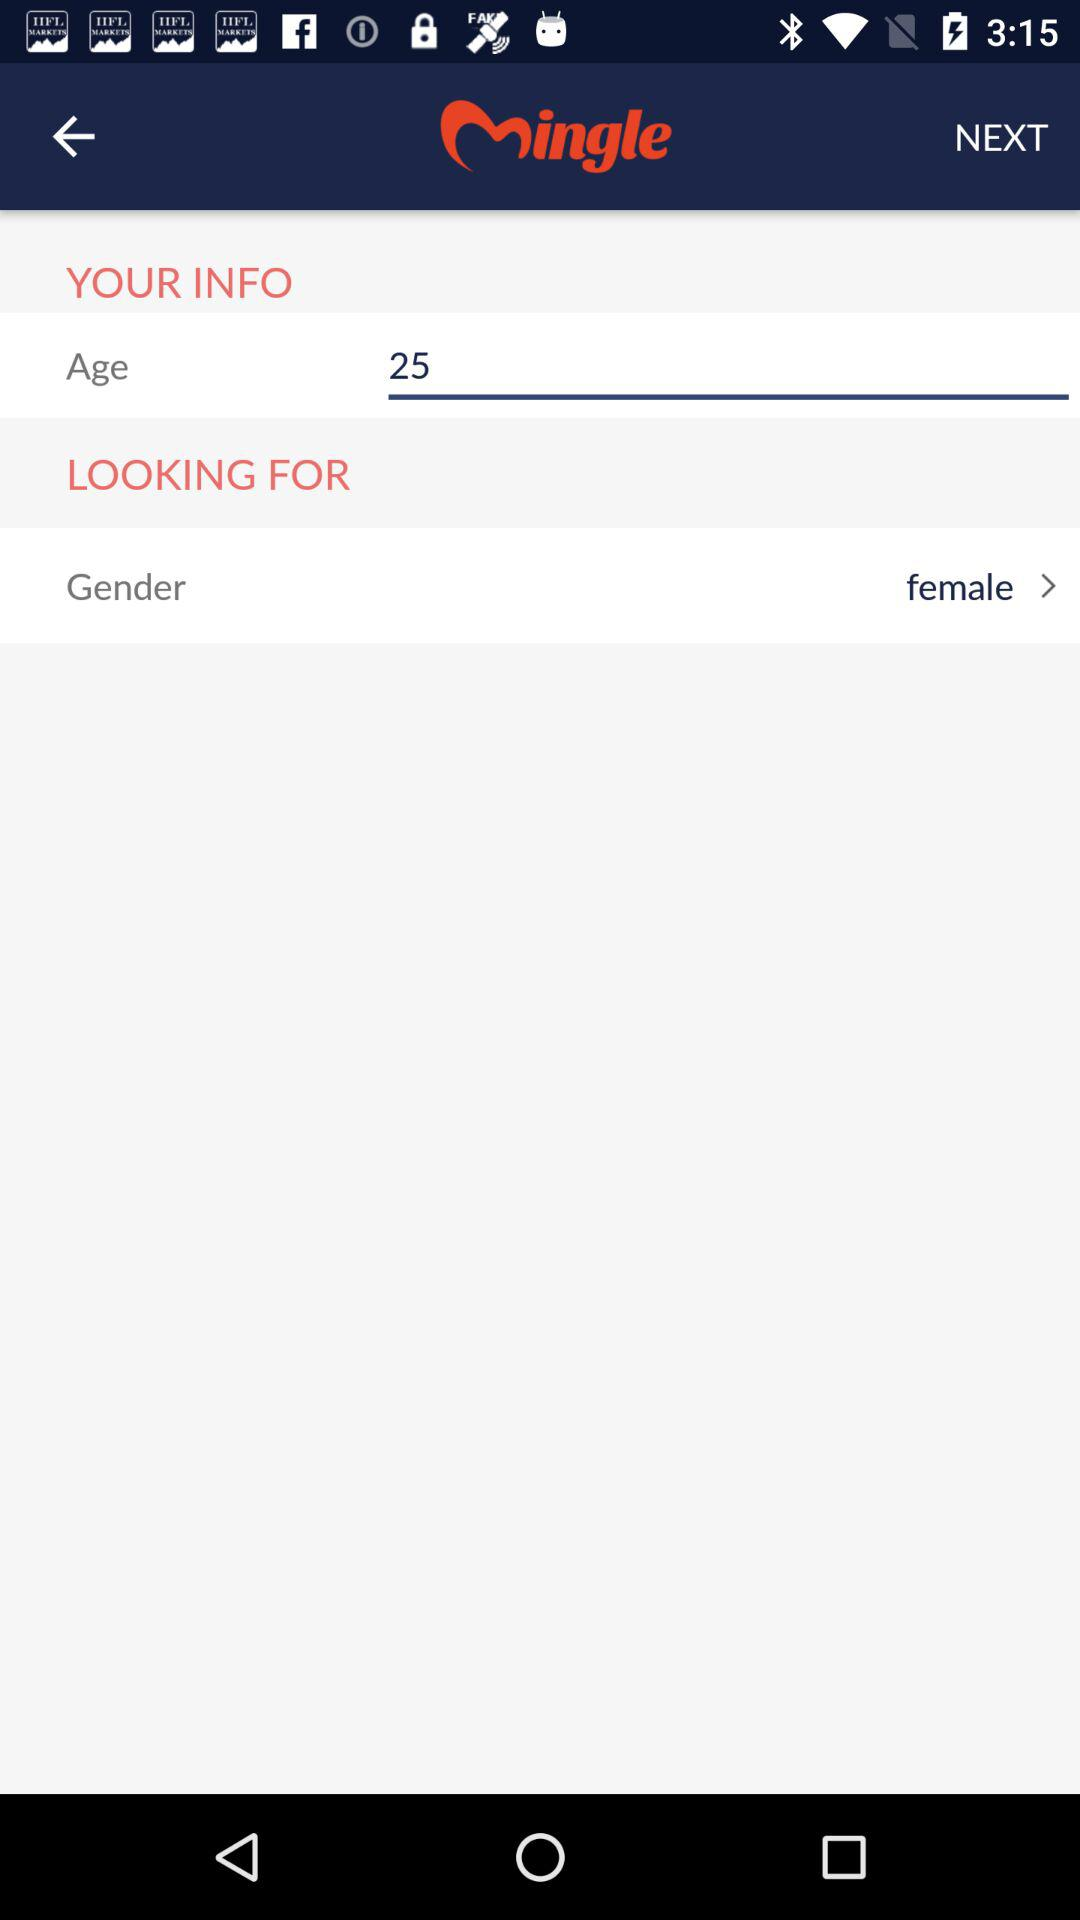What is the gender? The gender is female. 